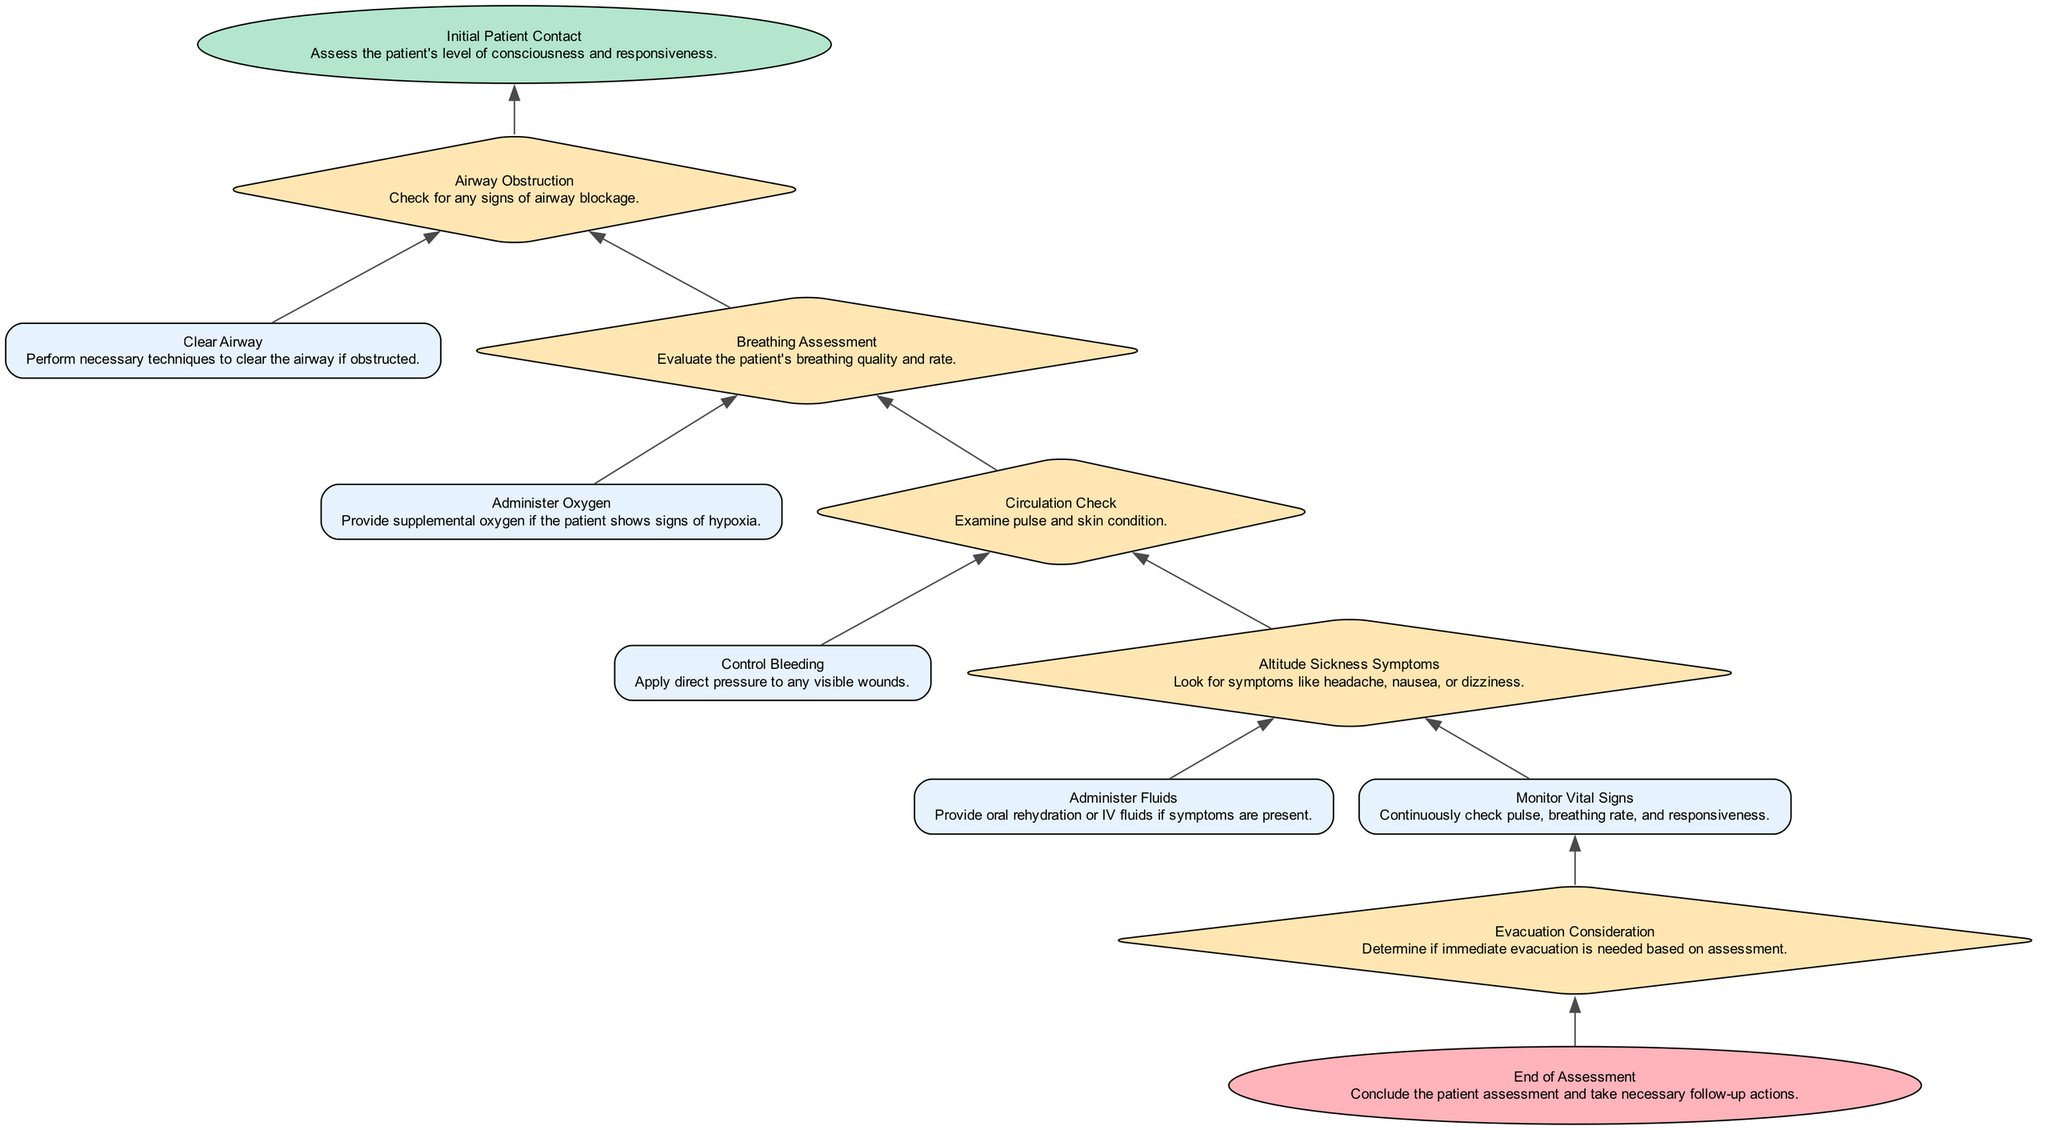What is the starting point of the flowchart? The starting point of the flowchart is the "Initial Patient Contact" node, which initiates the assessment process.
Answer: Initial Patient Contact How many decision points are in the flowchart? There are five decision points in the flowchart: "Airway Obstruction," "Breathing Assessment," "Circulation Check," "Altitude Sickness Symptoms," and "Evacuation Consideration."
Answer: 5 Which action follows the "Breathing Assessment" decision? After the "Breathing Assessment" decision, the "Administer Oxygen" action follows, providing supplemental oxygen if needed.
Answer: Administer Oxygen What symptoms should be looked for regarding altitude sickness? Symptoms to look for include headache, nausea, or dizziness as indicated in the "Altitude Sickness Symptoms" decision node.
Answer: headache, nausea, or dizziness What is the final action taken in the flowchart? The final action taken in the flowchart is labeled as "End of Assessment," concluding the patient assessment process.
Answer: End of Assessment What is the relationship between "Control Bleeding" and "Circulation Check"? The "Control Bleeding" action occurs after "Circulation Check," as it emphasizes the need to check circulation before addressing any visible wounds.
Answer: Control Bleeding If a patient shows signs of hypoxia, what immediate care response is indicated? If a patient shows signs of hypoxia, the indicated immediate care response is to "Administer Oxygen" as stated in the flowchart.
Answer: Administer Oxygen Which node represents a decision specifically about evacuation? The node that represents a decision about evacuation is "Evacuation Consideration," determining if immediate evacuation is necessary based on prior assessments.
Answer: Evacuation Consideration 